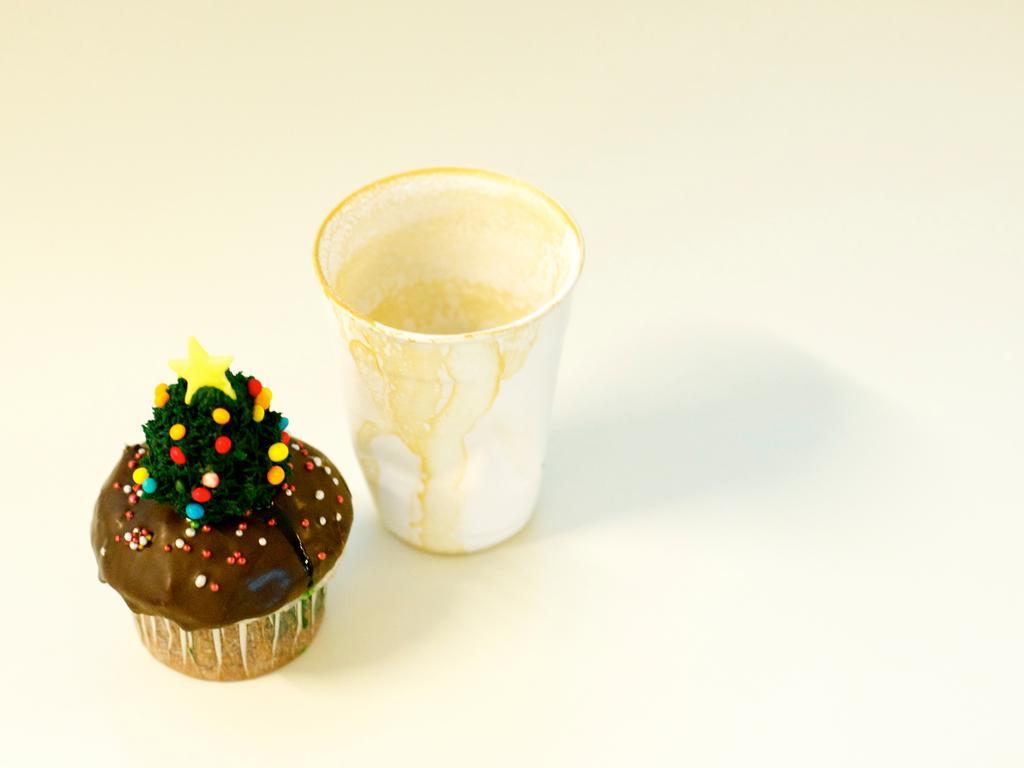Describe this image in one or two sentences. In this image we can see a cup and a cupcake on the white color surface. 